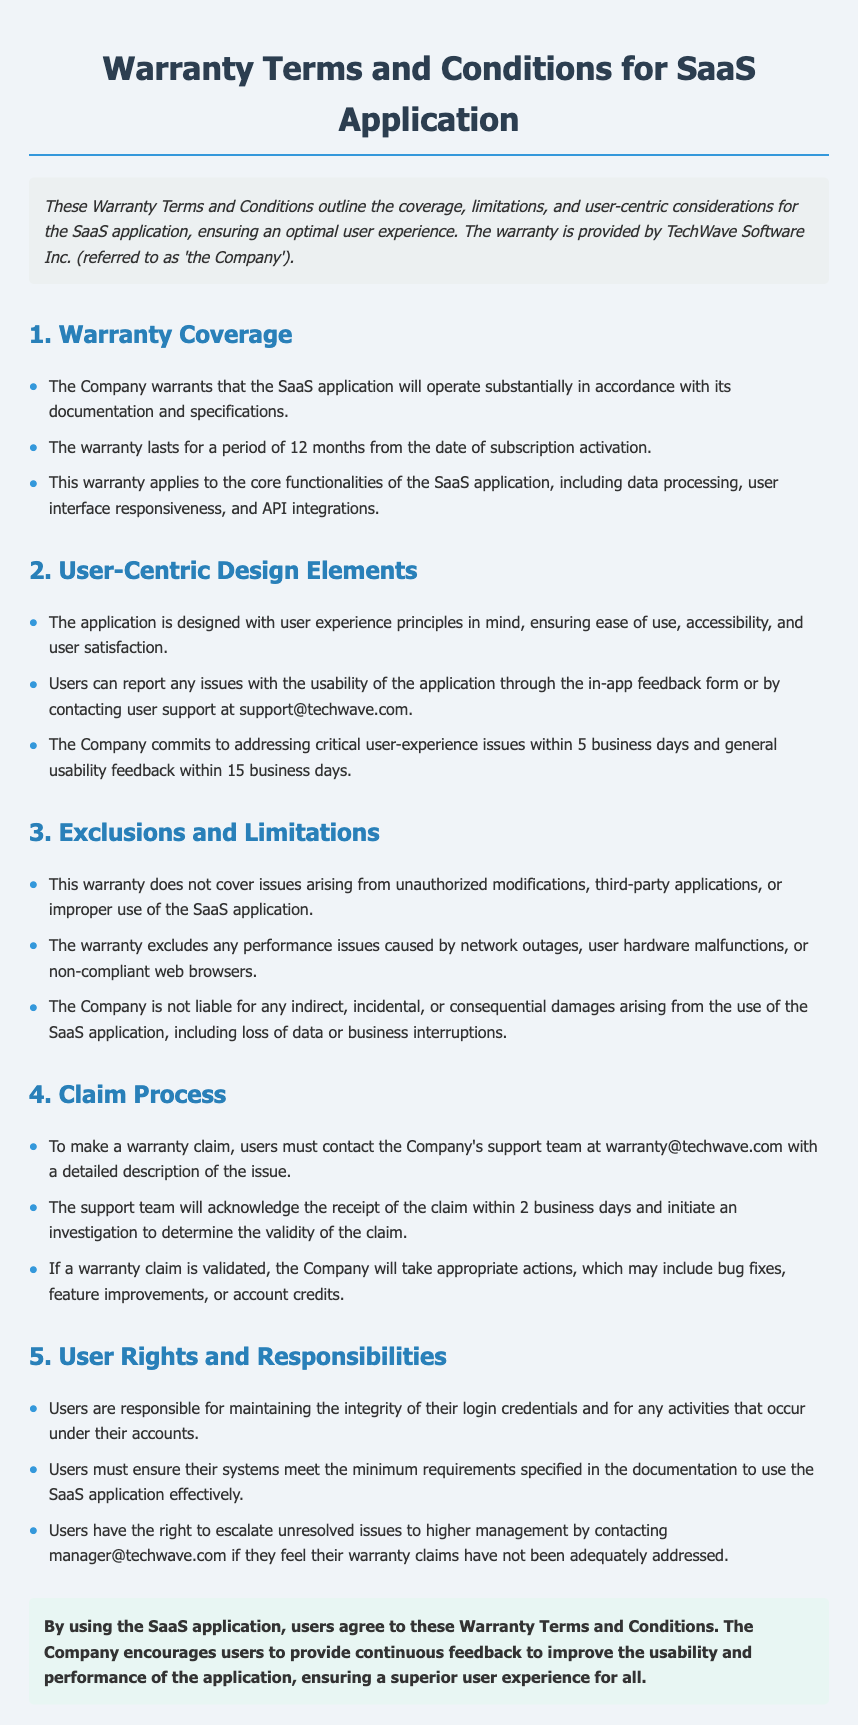What is the duration of the warranty? The warranty lasts for a period of 12 months from the date of subscription activation.
Answer: 12 months Who provides the warranty? The Company that provides the warranty is TechWave Software Inc.
Answer: TechWave Software Inc How should users report usability issues? Users can report issues with the usability of the application through the in-app feedback form or by contacting user support.
Answer: In-app feedback form or support@techwave.com What is excluded from the warranty coverage? The warranty does not cover issues arising from unauthorized modifications, third-party applications, or improper use of the SaaS application.
Answer: Unauthorized modifications, third-party applications, or improper use What is the timeline for addressing critical user-experience issues? The Company commits to addressing critical user-experience issues within 5 business days.
Answer: 5 business days What is the first step in making a warranty claim? To make a warranty claim, users must contact the Company's support team at warranty@techwave.com.
Answer: Contact warranty@techwave.com What rights do users have regarding unresolved issues? Users have the right to escalate unresolved issues to higher management by contacting manager@techwave.com.
Answer: Contact manager@techwave.com What is the maximum time for general usability feedback response? The Company commits to addressing general usability feedback within a specified period.
Answer: 15 business days 